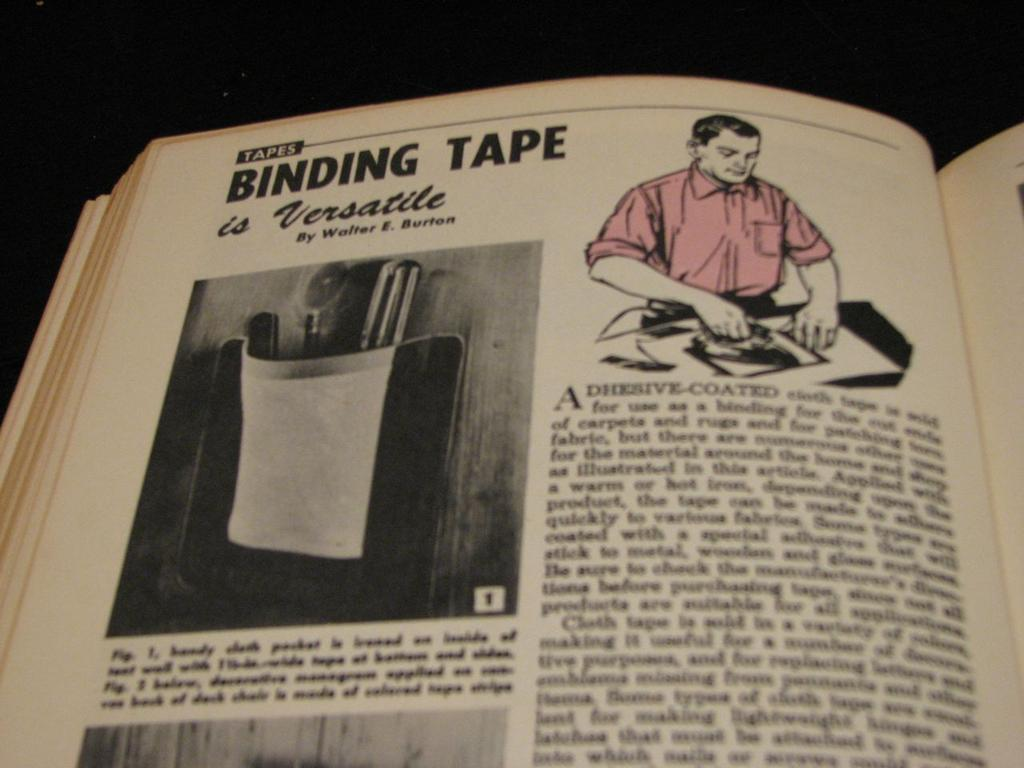<image>
Describe the image concisely. A book is open to a section on binding tape. 